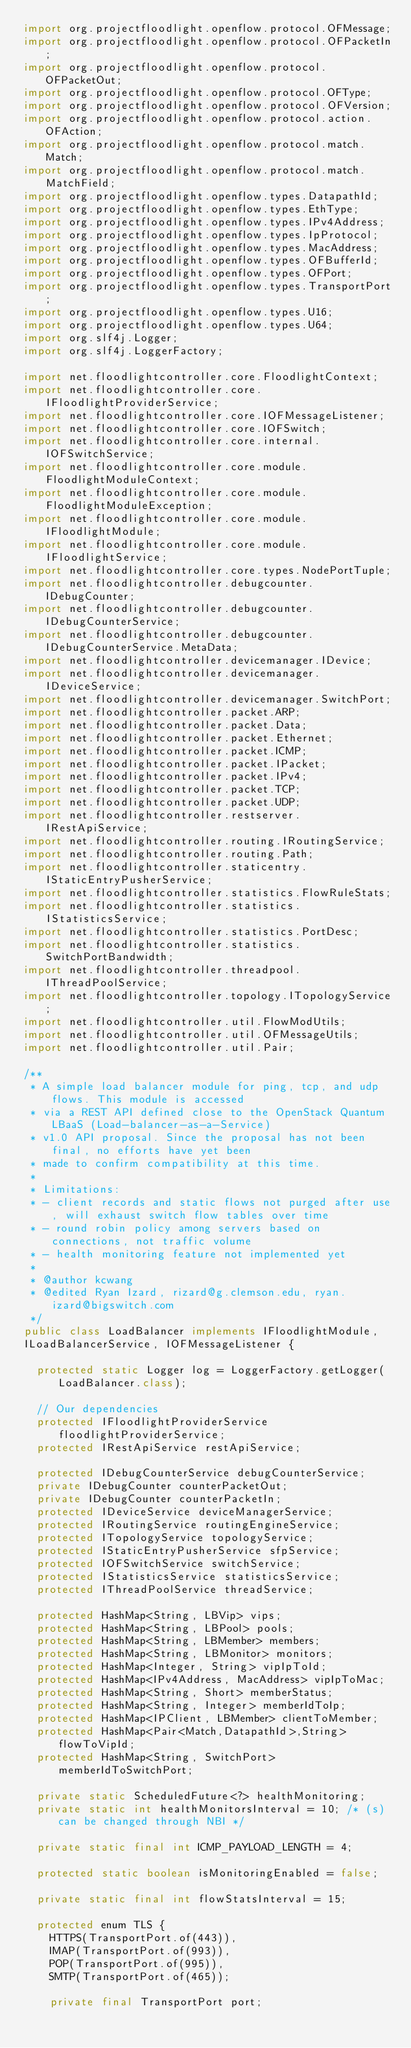Convert code to text. <code><loc_0><loc_0><loc_500><loc_500><_Java_>import org.projectfloodlight.openflow.protocol.OFMessage;
import org.projectfloodlight.openflow.protocol.OFPacketIn;
import org.projectfloodlight.openflow.protocol.OFPacketOut;
import org.projectfloodlight.openflow.protocol.OFType;
import org.projectfloodlight.openflow.protocol.OFVersion;
import org.projectfloodlight.openflow.protocol.action.OFAction;
import org.projectfloodlight.openflow.protocol.match.Match;
import org.projectfloodlight.openflow.protocol.match.MatchField;
import org.projectfloodlight.openflow.types.DatapathId;
import org.projectfloodlight.openflow.types.EthType;
import org.projectfloodlight.openflow.types.IPv4Address;
import org.projectfloodlight.openflow.types.IpProtocol;
import org.projectfloodlight.openflow.types.MacAddress;
import org.projectfloodlight.openflow.types.OFBufferId;
import org.projectfloodlight.openflow.types.OFPort;
import org.projectfloodlight.openflow.types.TransportPort;
import org.projectfloodlight.openflow.types.U16;
import org.projectfloodlight.openflow.types.U64;
import org.slf4j.Logger;
import org.slf4j.LoggerFactory;

import net.floodlightcontroller.core.FloodlightContext;
import net.floodlightcontroller.core.IFloodlightProviderService;
import net.floodlightcontroller.core.IOFMessageListener;
import net.floodlightcontroller.core.IOFSwitch;
import net.floodlightcontroller.core.internal.IOFSwitchService;
import net.floodlightcontroller.core.module.FloodlightModuleContext;
import net.floodlightcontroller.core.module.FloodlightModuleException;
import net.floodlightcontroller.core.module.IFloodlightModule;
import net.floodlightcontroller.core.module.IFloodlightService;
import net.floodlightcontroller.core.types.NodePortTuple;
import net.floodlightcontroller.debugcounter.IDebugCounter;
import net.floodlightcontroller.debugcounter.IDebugCounterService;
import net.floodlightcontroller.debugcounter.IDebugCounterService.MetaData;
import net.floodlightcontroller.devicemanager.IDevice;
import net.floodlightcontroller.devicemanager.IDeviceService;
import net.floodlightcontroller.devicemanager.SwitchPort;
import net.floodlightcontroller.packet.ARP;
import net.floodlightcontroller.packet.Data;
import net.floodlightcontroller.packet.Ethernet;
import net.floodlightcontroller.packet.ICMP;
import net.floodlightcontroller.packet.IPacket;
import net.floodlightcontroller.packet.IPv4;
import net.floodlightcontroller.packet.TCP;
import net.floodlightcontroller.packet.UDP;
import net.floodlightcontroller.restserver.IRestApiService;
import net.floodlightcontroller.routing.IRoutingService;
import net.floodlightcontroller.routing.Path;
import net.floodlightcontroller.staticentry.IStaticEntryPusherService;
import net.floodlightcontroller.statistics.FlowRuleStats;
import net.floodlightcontroller.statistics.IStatisticsService;
import net.floodlightcontroller.statistics.PortDesc;
import net.floodlightcontroller.statistics.SwitchPortBandwidth;
import net.floodlightcontroller.threadpool.IThreadPoolService;
import net.floodlightcontroller.topology.ITopologyService;
import net.floodlightcontroller.util.FlowModUtils;
import net.floodlightcontroller.util.OFMessageUtils;
import net.floodlightcontroller.util.Pair;

/**
 * A simple load balancer module for ping, tcp, and udp flows. This module is accessed 
 * via a REST API defined close to the OpenStack Quantum LBaaS (Load-balancer-as-a-Service)
 * v1.0 API proposal. Since the proposal has not been final, no efforts have yet been 
 * made to confirm compatibility at this time. 
 * 
 * Limitations:
 * - client records and static flows not purged after use, will exhaust switch flow tables over time
 * - round robin policy among servers based on connections, not traffic volume
 * - health monitoring feature not implemented yet
 *  
 * @author kcwang
 * @edited Ryan Izard, rizard@g.clemson.edu, ryan.izard@bigswitch.com
 */
public class LoadBalancer implements IFloodlightModule,
ILoadBalancerService, IOFMessageListener {

	protected static Logger log = LoggerFactory.getLogger(LoadBalancer.class);

	// Our dependencies
	protected IFloodlightProviderService floodlightProviderService;
	protected IRestApiService restApiService;

	protected IDebugCounterService debugCounterService;
	private IDebugCounter counterPacketOut;
	private IDebugCounter counterPacketIn;
	protected IDeviceService deviceManagerService;
	protected IRoutingService routingEngineService;
	protected ITopologyService topologyService;
	protected IStaticEntryPusherService sfpService;
	protected IOFSwitchService switchService;
	protected IStatisticsService statisticsService;
	protected IThreadPoolService threadService;

	protected HashMap<String, LBVip> vips;
	protected HashMap<String, LBPool> pools;
	protected HashMap<String, LBMember> members;
	protected HashMap<String, LBMonitor> monitors;
	protected HashMap<Integer, String> vipIpToId;
	protected HashMap<IPv4Address, MacAddress> vipIpToMac;
	protected HashMap<String, Short> memberStatus;
	protected HashMap<String, Integer> memberIdToIp;
	protected HashMap<IPClient, LBMember> clientToMember;
	protected HashMap<Pair<Match,DatapathId>,String> flowToVipId;
	protected HashMap<String, SwitchPort> memberIdToSwitchPort;

	private static ScheduledFuture<?> healthMonitoring;
	private static int healthMonitorsInterval = 10; /* (s) can be changed through NBI */

	private static final int ICMP_PAYLOAD_LENGTH = 4;

	protected static boolean isMonitoringEnabled = false;

	private static final int flowStatsInterval = 15;

	protected enum TLS {
		HTTPS(TransportPort.of(443)),
		IMAP(TransportPort.of(993)),
		POP(TransportPort.of(995)),
		SMTP(TransportPort.of(465));

		private final TransportPort port;</code> 